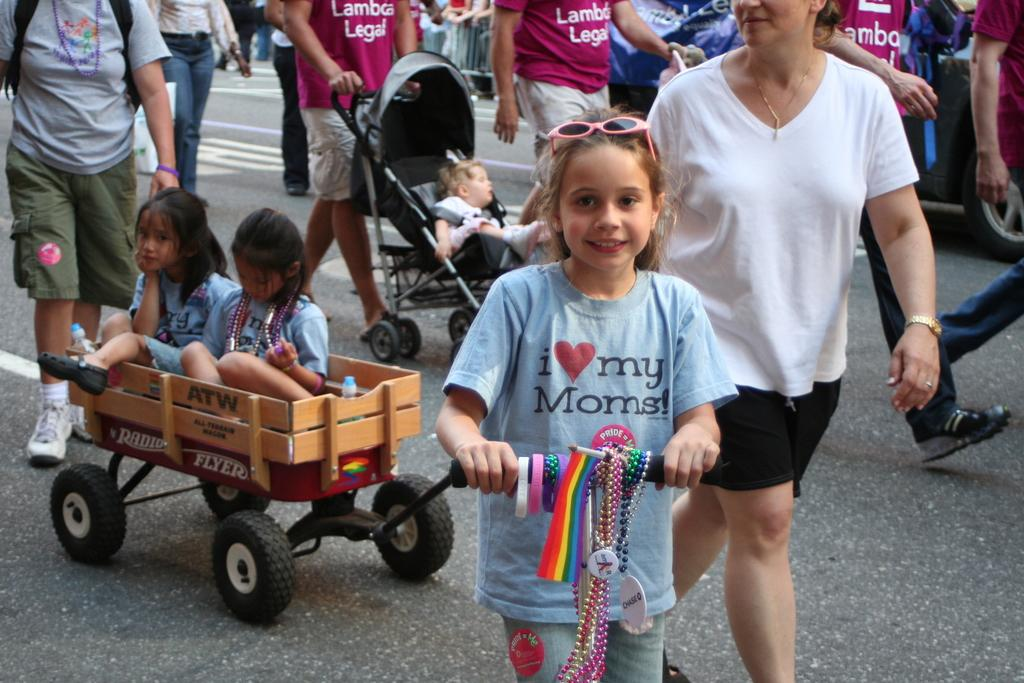What is happening with the group of people in the image? The people are walking on the road in the image. Can you describe the composition of the group? There are girls in the group, and there is a stroller with a child in it. What can be seen in the background of the image? There is a fence and a vehicle in the background of the image. What rhythm is the group of people following while walking in the image? There is no indication of a specific rhythm in the image; the group is simply walking on the road. 